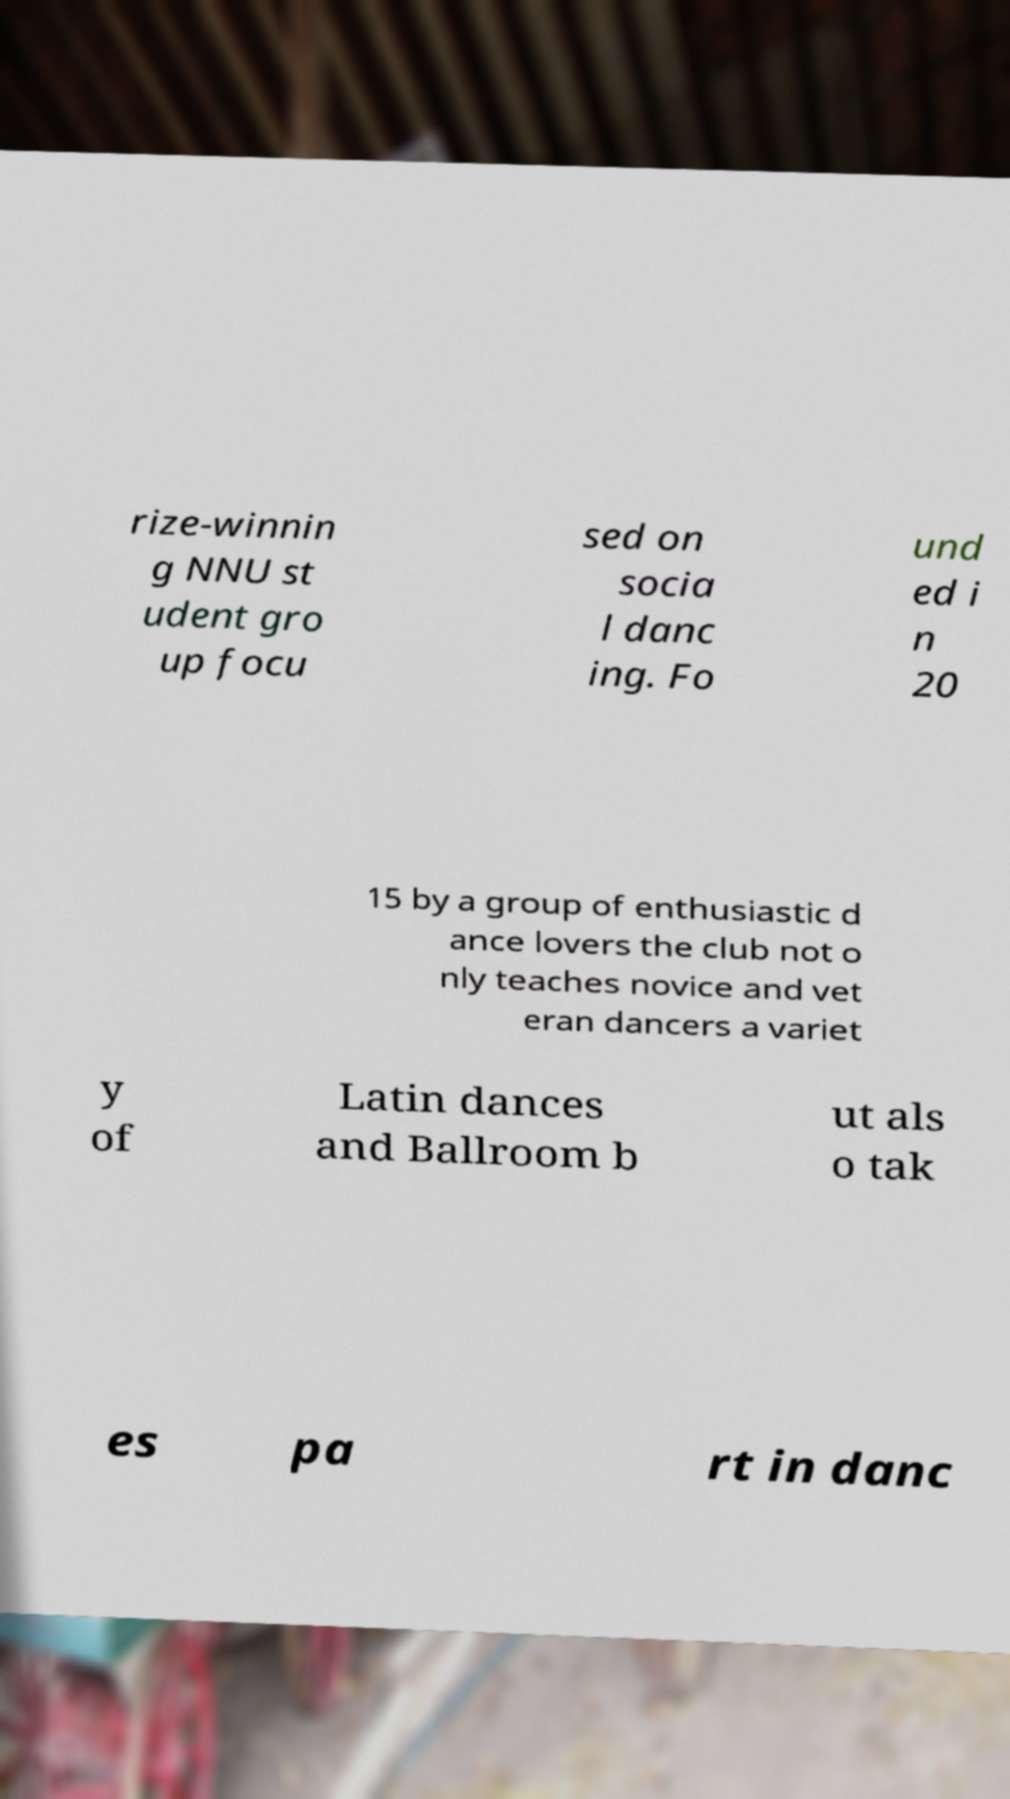What messages or text are displayed in this image? I need them in a readable, typed format. rize-winnin g NNU st udent gro up focu sed on socia l danc ing. Fo und ed i n 20 15 by a group of enthusiastic d ance lovers the club not o nly teaches novice and vet eran dancers a variet y of Latin dances and Ballroom b ut als o tak es pa rt in danc 